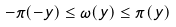Convert formula to latex. <formula><loc_0><loc_0><loc_500><loc_500>- \pi ( - y ) \leq \omega ( y ) \leq \pi ( y )</formula> 